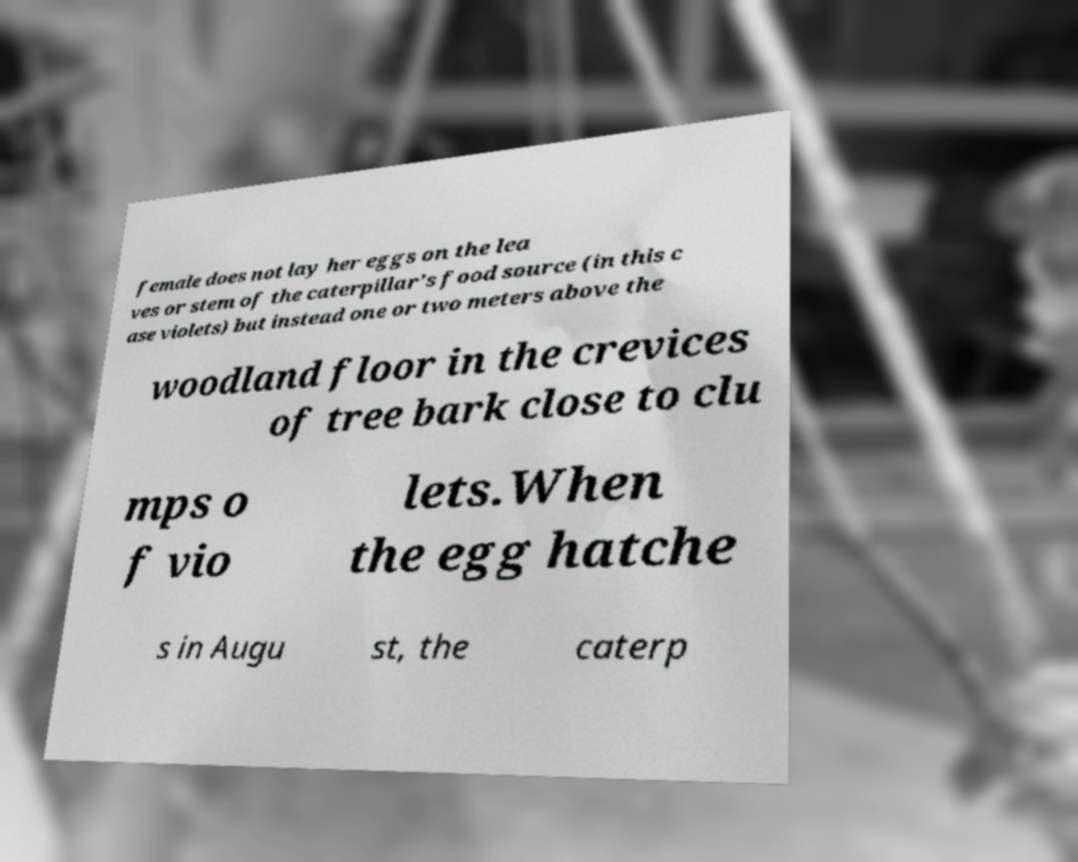Can you accurately transcribe the text from the provided image for me? female does not lay her eggs on the lea ves or stem of the caterpillar's food source (in this c ase violets) but instead one or two meters above the woodland floor in the crevices of tree bark close to clu mps o f vio lets.When the egg hatche s in Augu st, the caterp 